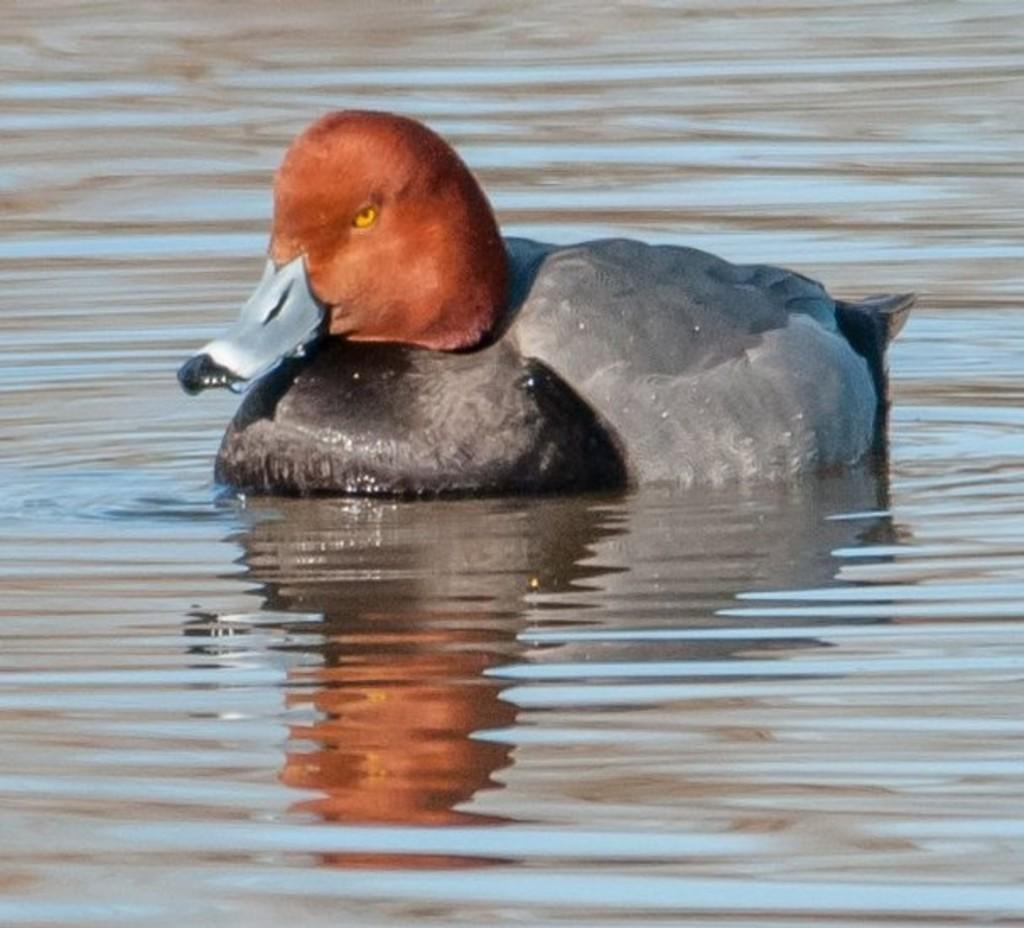What is the main element present in the image? There is water in the image. Are there any living creatures visible in the image? Yes, there is a duck in the image. Can you see a giraffe flying a kite in the image? No, there is no giraffe or kite present in the image. 